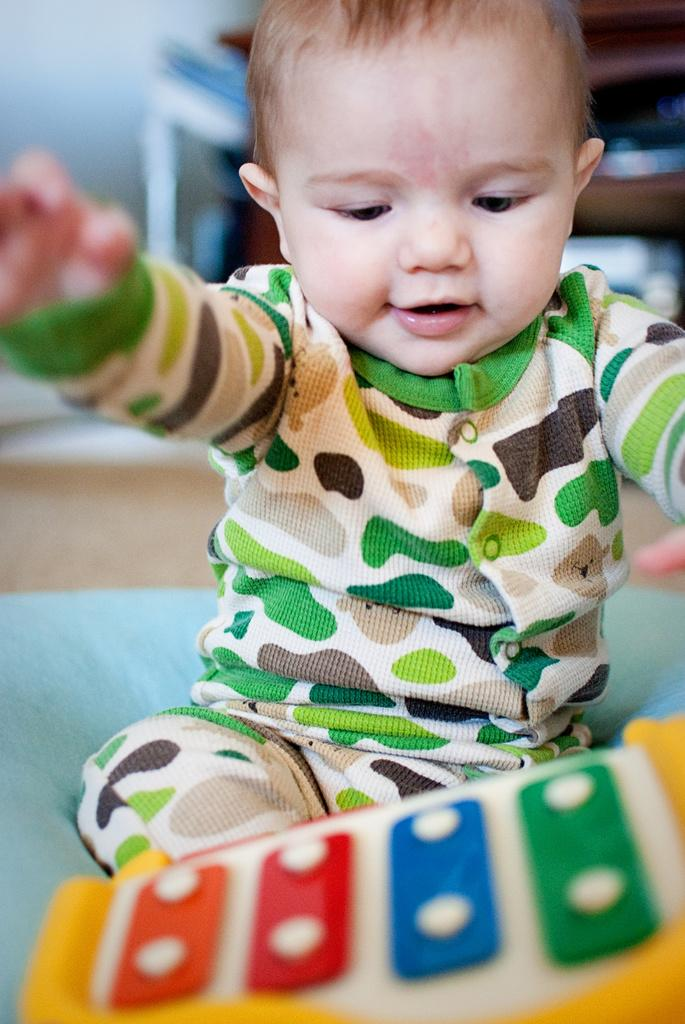What is the main subject of the image? There is a child in the image. What is the child doing in the image? The child is playing with a toy. Where is the toy located in the image? The toy is present at the bottom of the image. What type of collar can be seen on the dinosaur in the image? There are no dinosaurs or collars present in the image. 